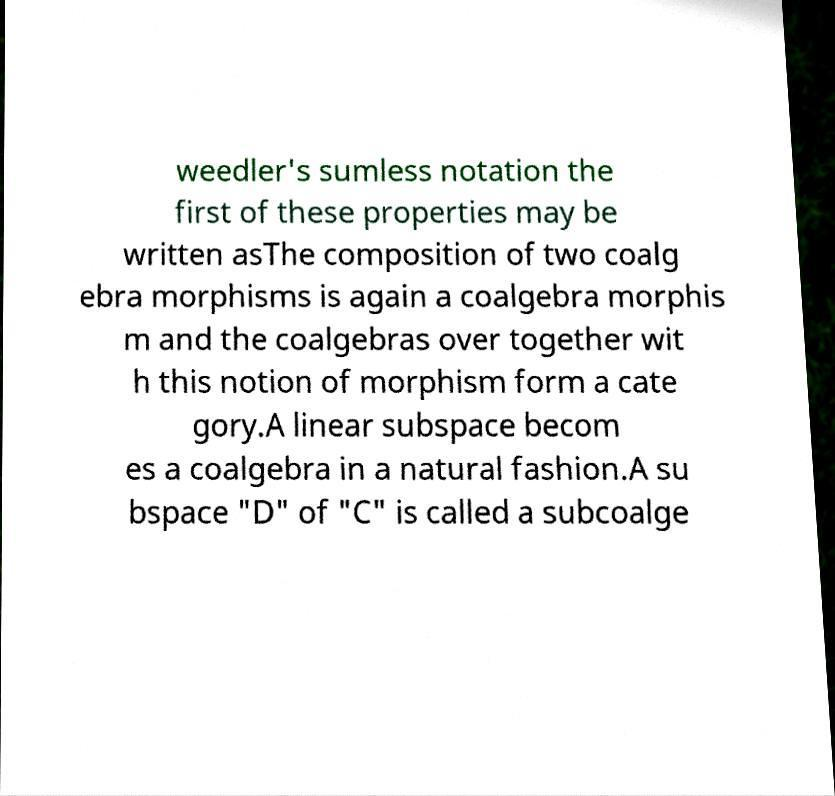Please identify and transcribe the text found in this image. weedler's sumless notation the first of these properties may be written asThe composition of two coalg ebra morphisms is again a coalgebra morphis m and the coalgebras over together wit h this notion of morphism form a cate gory.A linear subspace becom es a coalgebra in a natural fashion.A su bspace "D" of "C" is called a subcoalge 